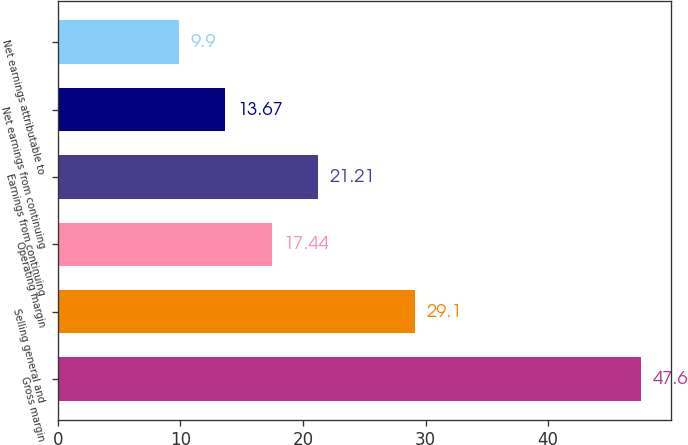Convert chart. <chart><loc_0><loc_0><loc_500><loc_500><bar_chart><fcel>Gross margin<fcel>Selling general and<fcel>Operating margin<fcel>Earnings from continuing<fcel>Net earnings from continuing<fcel>Net earnings attributable to<nl><fcel>47.6<fcel>29.1<fcel>17.44<fcel>21.21<fcel>13.67<fcel>9.9<nl></chart> 